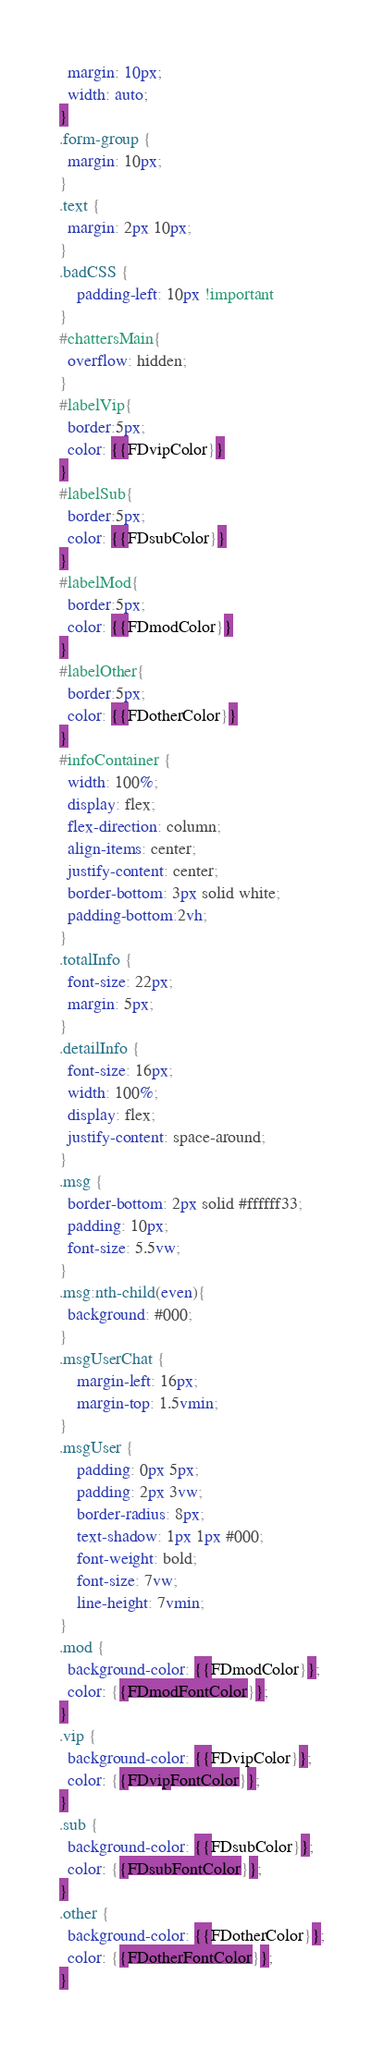<code> <loc_0><loc_0><loc_500><loc_500><_CSS_>  margin: 10px;
  width: auto;
}
.form-group {
  margin: 10px;
}
.text {
  margin: 2px 10px;
}
.badCSS {
    padding-left: 10px !important
}
#chattersMain{
  overflow: hidden;
}
#labelVip{
  border:5px;
  color: {{FDvipColor}}
}
#labelSub{
  border:5px;
  color: {{FDsubColor}}
}
#labelMod{
  border:5px;
  color: {{FDmodColor}}
}
#labelOther{
  border:5px;
  color: {{FDotherColor}}
}
#infoContainer {
  width: 100%;
  display: flex;
  flex-direction: column;
  align-items: center;
  justify-content: center;
  border-bottom: 3px solid white;
  padding-bottom:2vh;
}
.totalInfo {
  font-size: 22px;
  margin: 5px;
}
.detailInfo {
  font-size: 16px;
  width: 100%;
  display: flex;
  justify-content: space-around;
}
.msg {
  border-bottom: 2px solid #ffffff33;
  padding: 10px;
  font-size: 5.5vw;
}
.msg:nth-child(even){
  background: #000;
}
.msgUserChat {
	margin-left: 16px;
    margin-top: 1.5vmin;
}
.msgUser {
    padding: 0px 5px;
    padding: 2px 3vw;
    border-radius: 8px;
    text-shadow: 1px 1px #000;
    font-weight: bold;
    font-size: 7vw;
    line-height: 7vmin;
}
.mod {
  background-color: {{FDmodColor}};
  color: {{FDmodFontColor}};
}
.vip {
  background-color: {{FDvipColor}};
  color: {{FDvipFontColor}};
}
.sub {
  background-color: {{FDsubColor}};
  color: {{FDsubFontColor}};
}
.other {
  background-color: {{FDotherColor}};
  color: {{FDotherFontColor}};
}
</code> 